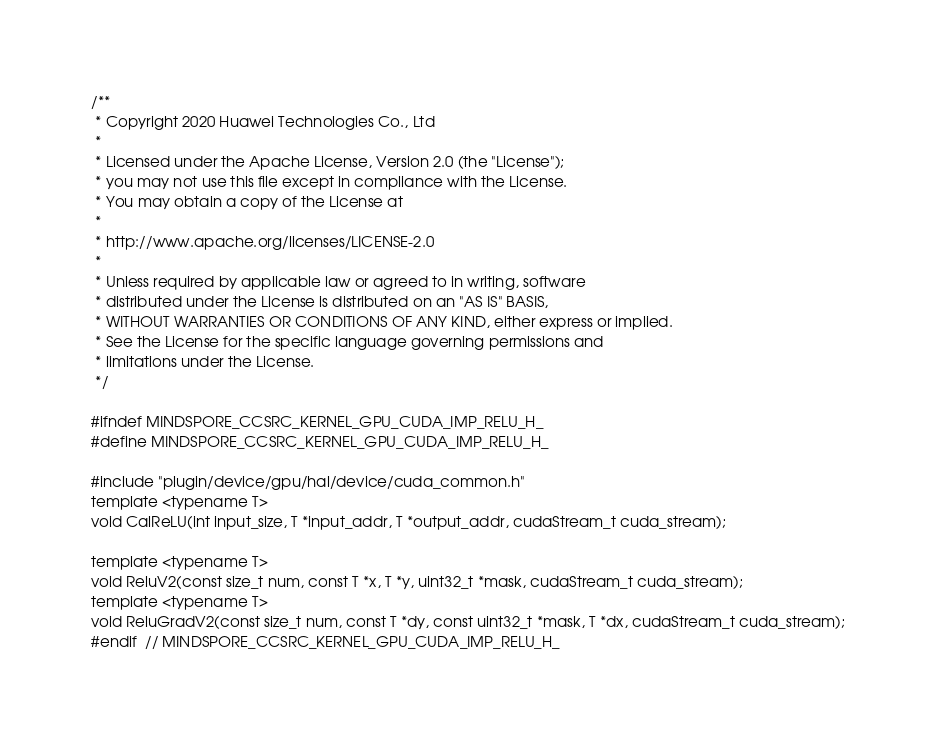Convert code to text. <code><loc_0><loc_0><loc_500><loc_500><_Cuda_>/**
 * Copyright 2020 Huawei Technologies Co., Ltd
 *
 * Licensed under the Apache License, Version 2.0 (the "License");
 * you may not use this file except in compliance with the License.
 * You may obtain a copy of the License at
 *
 * http://www.apache.org/licenses/LICENSE-2.0
 *
 * Unless required by applicable law or agreed to in writing, software
 * distributed under the License is distributed on an "AS IS" BASIS,
 * WITHOUT WARRANTIES OR CONDITIONS OF ANY KIND, either express or implied.
 * See the License for the specific language governing permissions and
 * limitations under the License.
 */

#ifndef MINDSPORE_CCSRC_KERNEL_GPU_CUDA_IMP_RELU_H_
#define MINDSPORE_CCSRC_KERNEL_GPU_CUDA_IMP_RELU_H_

#include "plugin/device/gpu/hal/device/cuda_common.h"
template <typename T>
void CalReLU(int input_size, T *input_addr, T *output_addr, cudaStream_t cuda_stream);

template <typename T>
void ReluV2(const size_t num, const T *x, T *y, uint32_t *mask, cudaStream_t cuda_stream);
template <typename T>
void ReluGradV2(const size_t num, const T *dy, const uint32_t *mask, T *dx, cudaStream_t cuda_stream);
#endif  // MINDSPORE_CCSRC_KERNEL_GPU_CUDA_IMP_RELU_H_
</code> 